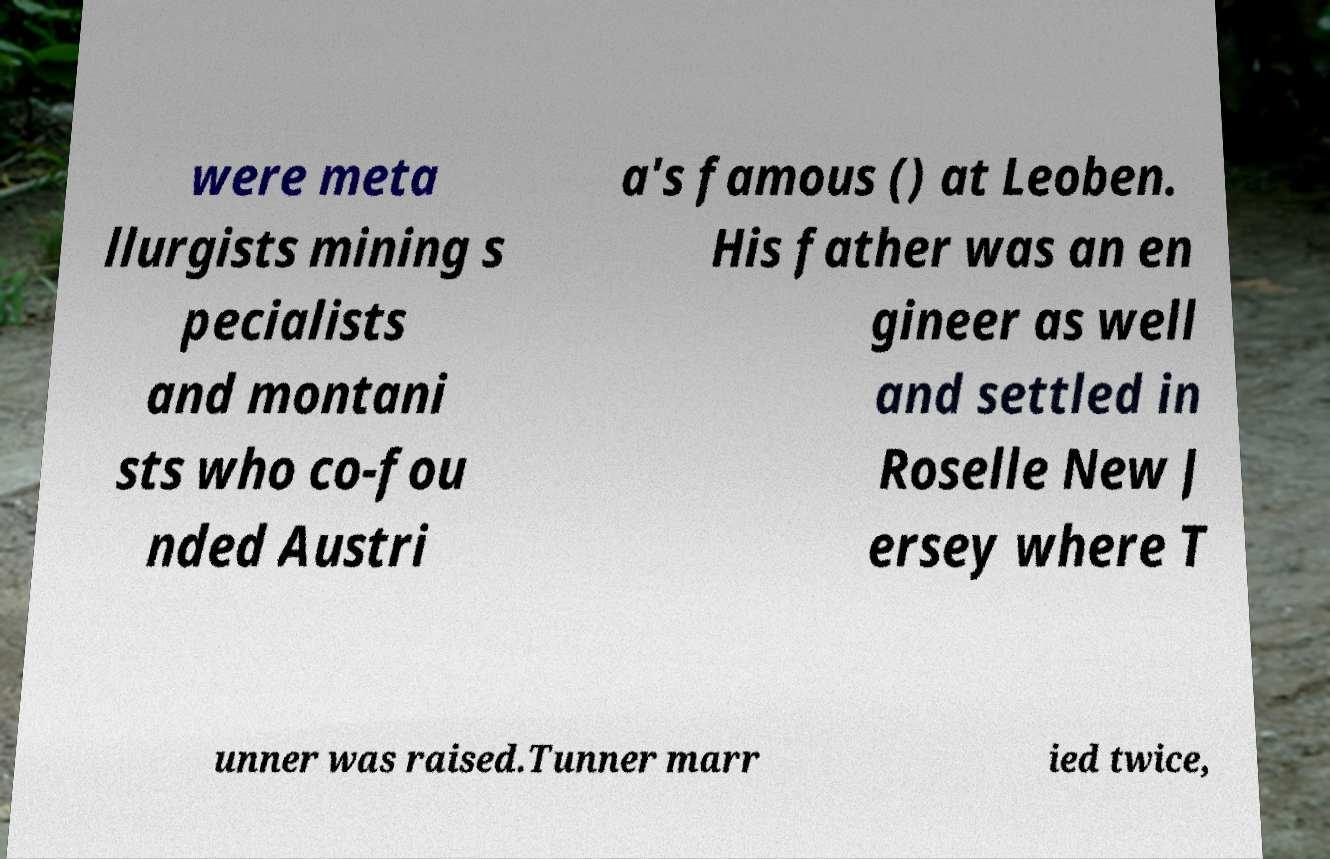I need the written content from this picture converted into text. Can you do that? were meta llurgists mining s pecialists and montani sts who co-fou nded Austri a's famous () at Leoben. His father was an en gineer as well and settled in Roselle New J ersey where T unner was raised.Tunner marr ied twice, 